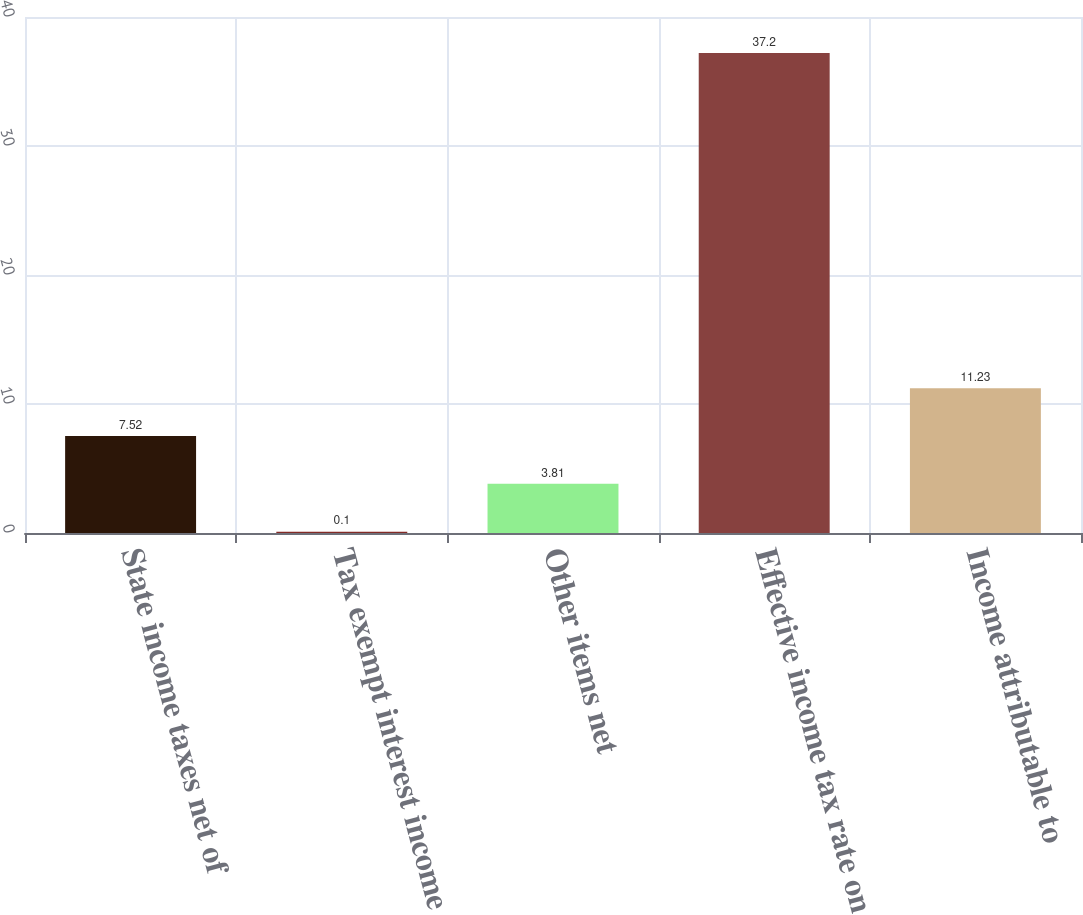Convert chart. <chart><loc_0><loc_0><loc_500><loc_500><bar_chart><fcel>State income taxes net of<fcel>Tax exempt interest income<fcel>Other items net<fcel>Effective income tax rate on<fcel>Income attributable to<nl><fcel>7.52<fcel>0.1<fcel>3.81<fcel>37.2<fcel>11.23<nl></chart> 